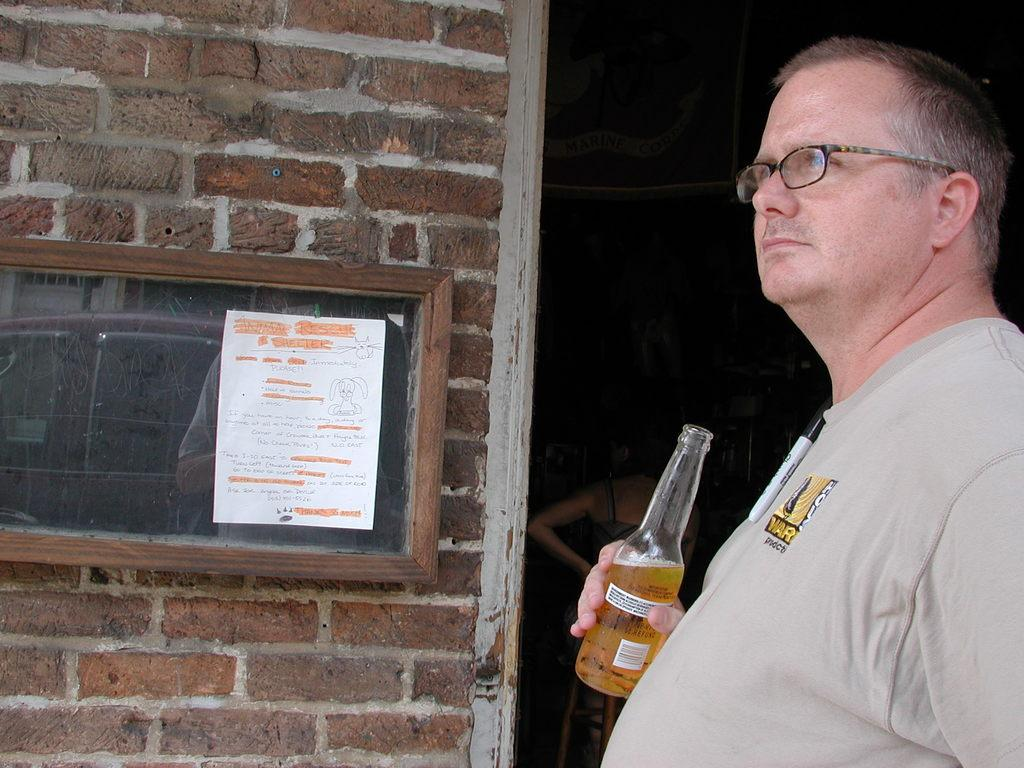What is the man in the image doing? The man is standing in the image and holding a wine bottle in his hand. What can be seen on the left side of the image? There is a brick wall, a board, and a car on the left side of the image. Can you describe the background of the image? In the background of the image, there is a woman and a hoarding. What is the man holding in his hand? The man is holding a wine bottle in his hand. What type of suit is the engine wearing in the image? There is no engine present in the image, and therefore no suit can be associated with it. 